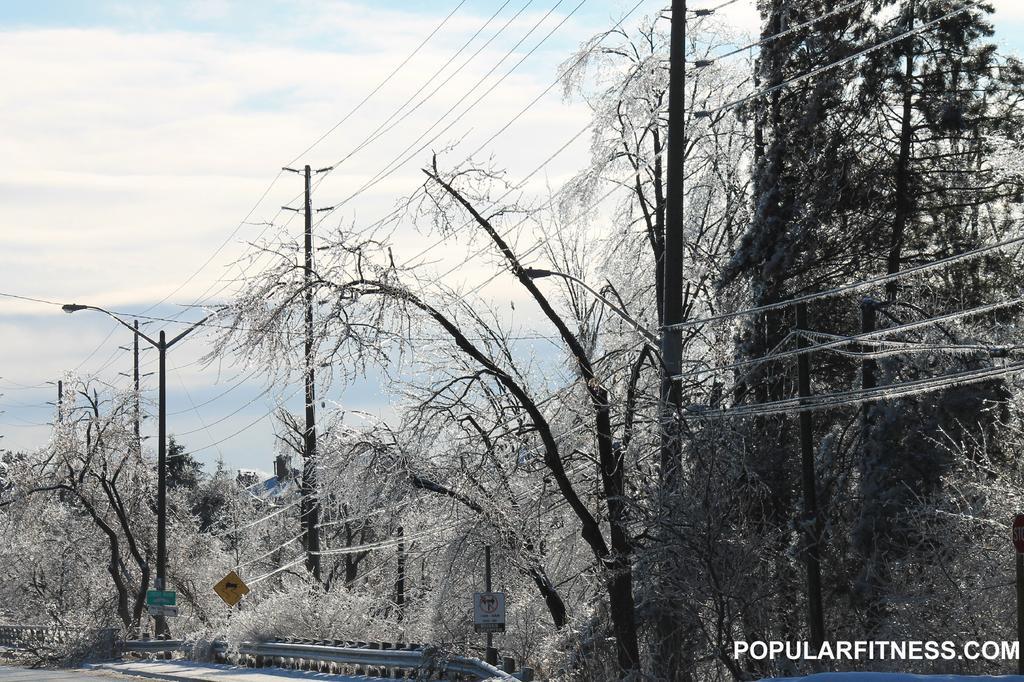How would you summarize this image in a sentence or two? Here in this picture we can see plants and trees present on the ground and we can also see light posts and electric poles present and we can see cable wires hanging through the poles and we can see the sky is fully covered with clouds. 